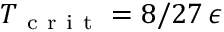<formula> <loc_0><loc_0><loc_500><loc_500>T _ { c r i t } = 8 / 2 7 \, \epsilon</formula> 